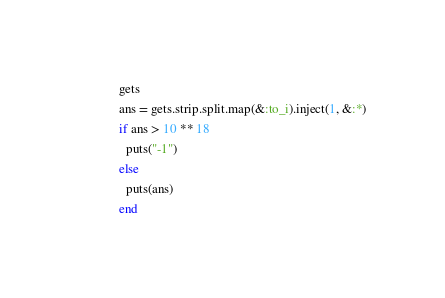Convert code to text. <code><loc_0><loc_0><loc_500><loc_500><_Ruby_>gets
ans = gets.strip.split.map(&:to_i).inject(1, &:*)
if ans > 10 ** 18
  puts("-1")
else
  puts(ans)
end
</code> 